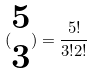<formula> <loc_0><loc_0><loc_500><loc_500>( \begin{matrix} 5 \\ 3 \end{matrix} ) = \frac { 5 ! } { 3 ! 2 ! }</formula> 